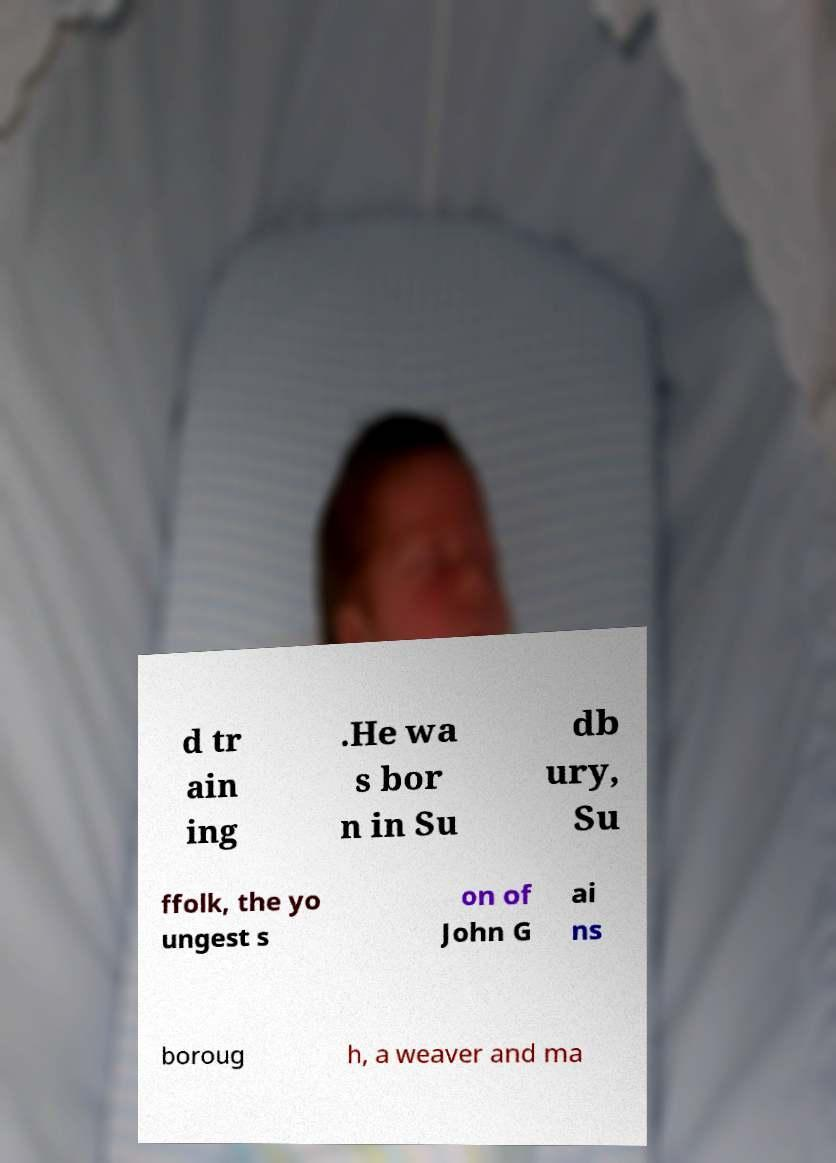There's text embedded in this image that I need extracted. Can you transcribe it verbatim? d tr ain ing .He wa s bor n in Su db ury, Su ffolk, the yo ungest s on of John G ai ns boroug h, a weaver and ma 